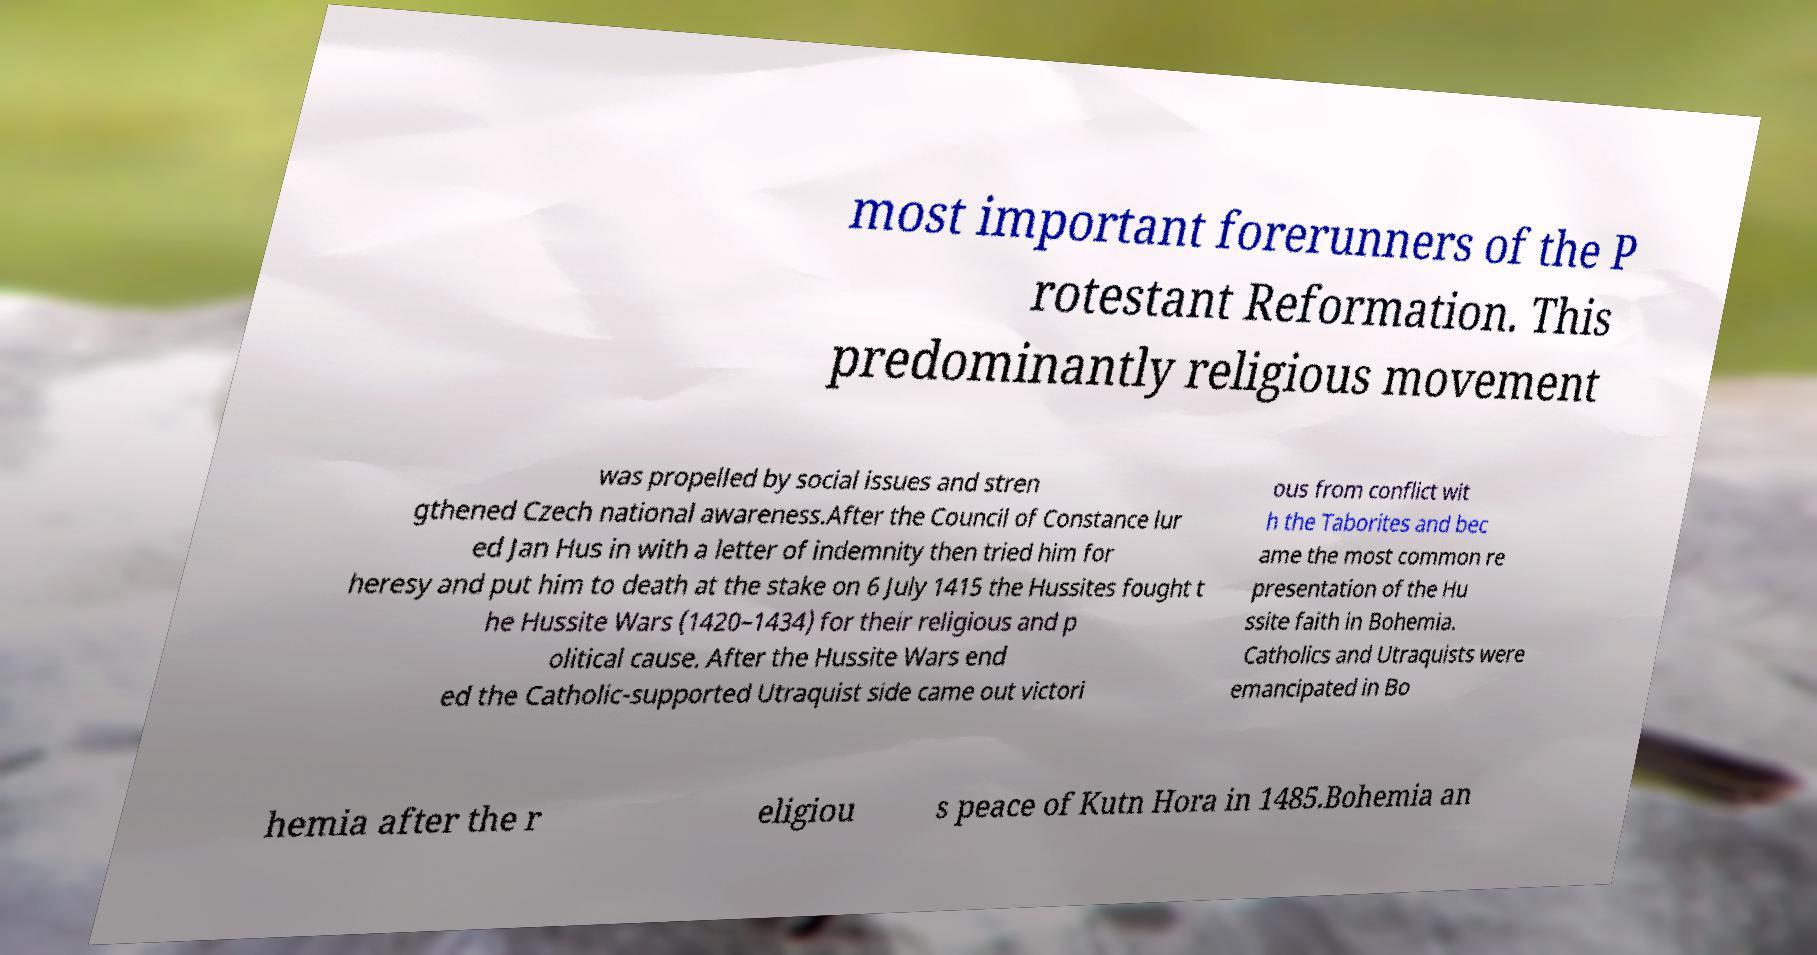I need the written content from this picture converted into text. Can you do that? most important forerunners of the P rotestant Reformation. This predominantly religious movement was propelled by social issues and stren gthened Czech national awareness.After the Council of Constance lur ed Jan Hus in with a letter of indemnity then tried him for heresy and put him to death at the stake on 6 July 1415 the Hussites fought t he Hussite Wars (1420–1434) for their religious and p olitical cause. After the Hussite Wars end ed the Catholic-supported Utraquist side came out victori ous from conflict wit h the Taborites and bec ame the most common re presentation of the Hu ssite faith in Bohemia. Catholics and Utraquists were emancipated in Bo hemia after the r eligiou s peace of Kutn Hora in 1485.Bohemia an 